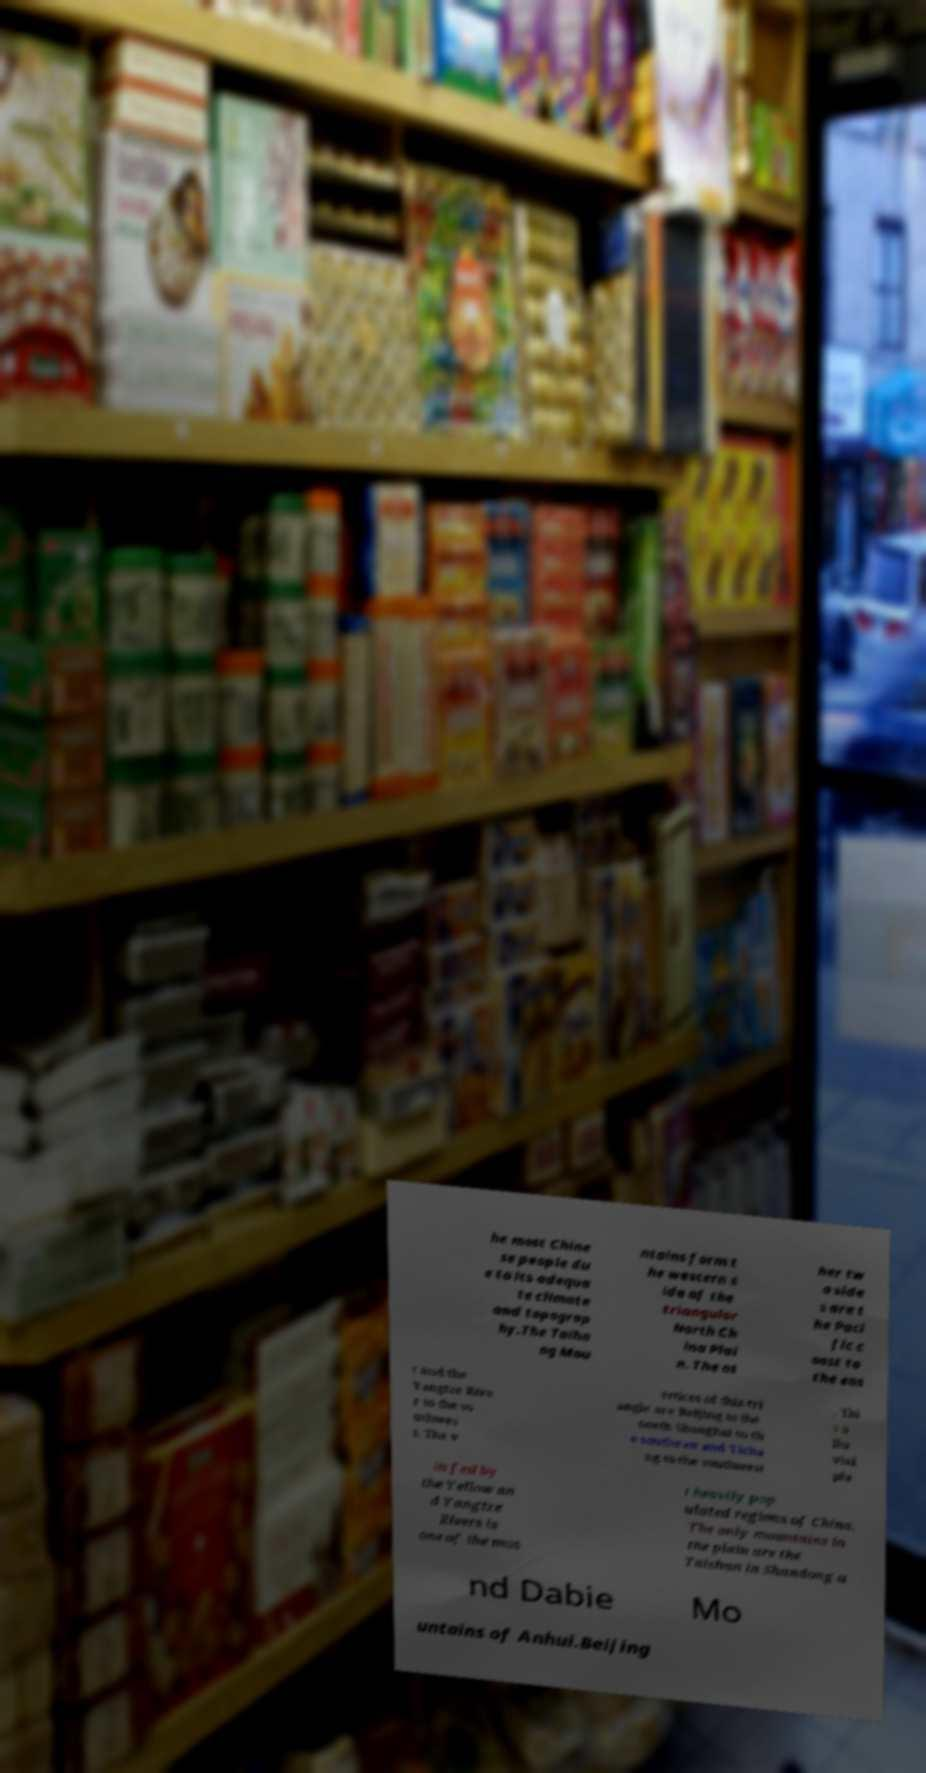I need the written content from this picture converted into text. Can you do that? he most Chine se people du e to its adequa te climate and topograp hy.The Taiha ng Mou ntains form t he western s ide of the triangular North Ch ina Plai n. The ot her tw o side s are t he Paci fic c oast to the eas t and the Yangtze Rive r to the so uthwes t. The v ertices of this tri angle are Beijing to the north Shanghai to th e southeast and Yicha ng to the southwest . Thi s a llu vial pla in fed by the Yellow an d Yangtze Rivers is one of the mos t heavily pop ulated regions of China. The only mountains in the plain are the Taishan in Shandong a nd Dabie Mo untains of Anhui.Beijing 